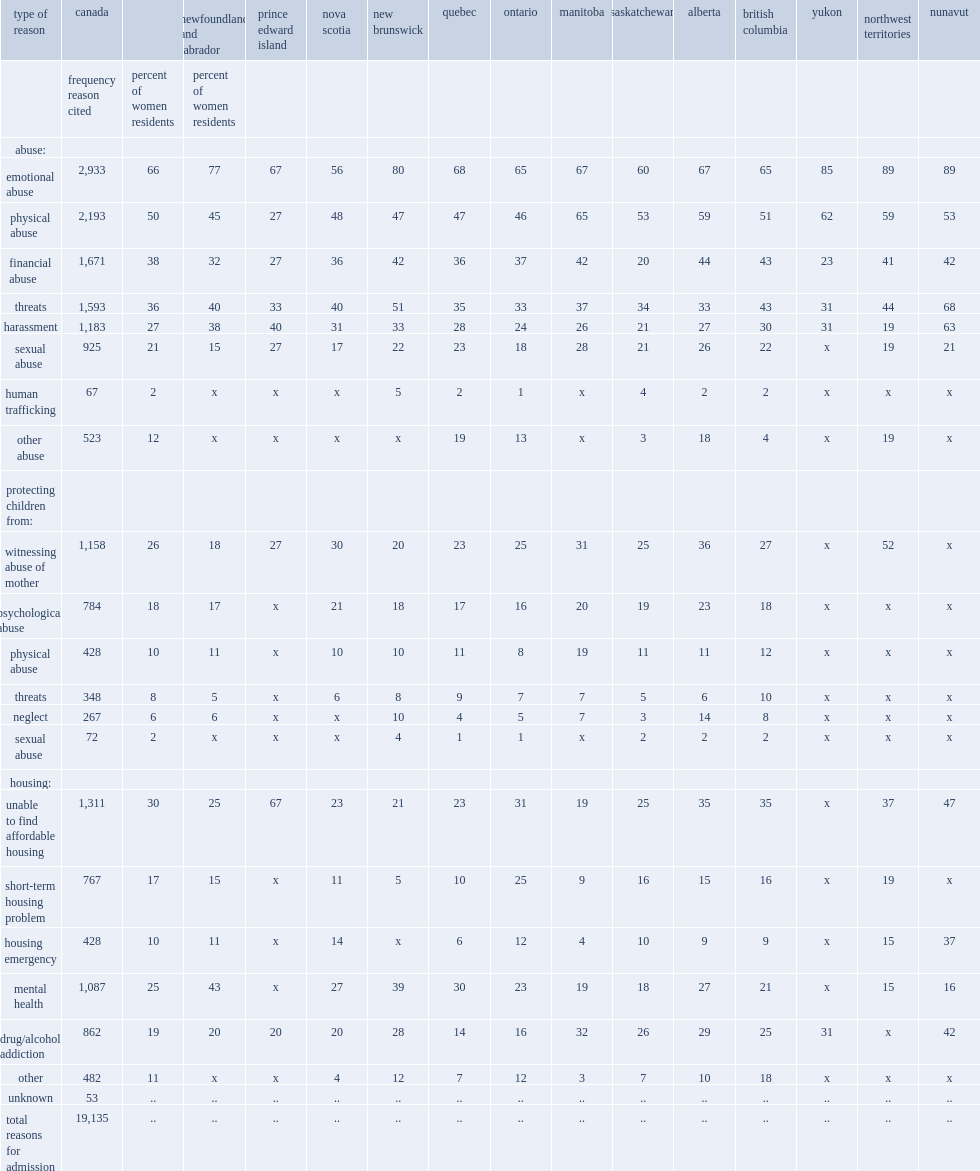What are the top two common reasons women sought shelter? Emotional abuse physical abuse. How many percent of women in shelters on the snapshot date have cited financial abuse as one of their reasons for seeking shelter? 38.0. How many percent of women in shelters on the snapshot date cited threats as one of their reasons for seeking shelter? 36.0. How many percent of women in shelters on the snapshot date cited harassment as one of their reasons for seeking shelter? 27.0. How many percent of women in shelters on the snapshot date cited sexual abuse as one of their reasons for seeking shelter? 21.0. How many percent of women in shelters on the snapshot date cited other abuse as one of their reasons for seeking shelter? 12.0. On that snapshot date, how many women have indicated human trafficking as a reason for seeking refuge? 67.0. How many percent of women have identified wanting to protect their children from witnessing abuse? 26.0. How many percent of women have identified wanting to protect their children from psychological abuse? 18.0. How many percent of women have identified wanting to protect their children from physical abuse as one of their reasons for seeking shelter? 10.0. How many percent of women have identified being unable to find affordable housing as one of their reasons for seeking shelter? 30.0. How many percent of women have cited short-term housing problems as one of their reasons for seeking shelter? 17.0. How many percent of women have reported housing emergencies as one of their reasons for seeking shelter? 10.0. Among all provinces and territories recorded in the table, which province has the highest proportion unable to find affordable housing? Prince edward island. On snapshot day, which provinces or territories has the highest proportion of women residents with mental health issues? Newfoundland and labrador. 